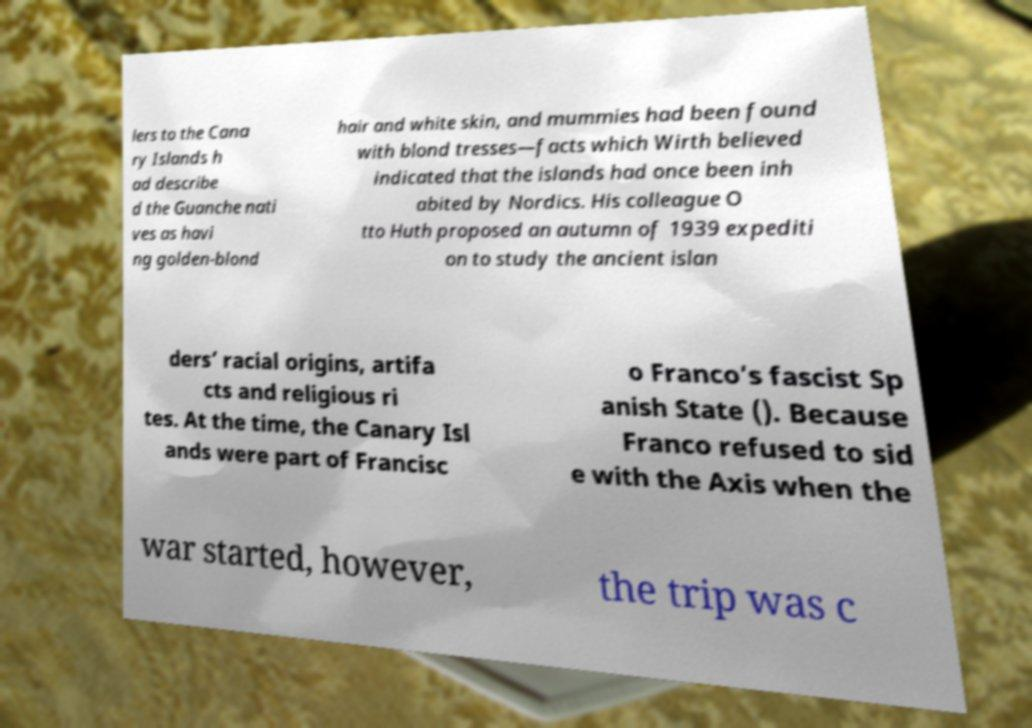I need the written content from this picture converted into text. Can you do that? lers to the Cana ry Islands h ad describe d the Guanche nati ves as havi ng golden-blond hair and white skin, and mummies had been found with blond tresses—facts which Wirth believed indicated that the islands had once been inh abited by Nordics. His colleague O tto Huth proposed an autumn of 1939 expediti on to study the ancient islan ders’ racial origins, artifa cts and religious ri tes. At the time, the Canary Isl ands were part of Francisc o Franco’s fascist Sp anish State (). Because Franco refused to sid e with the Axis when the war started, however, the trip was c 